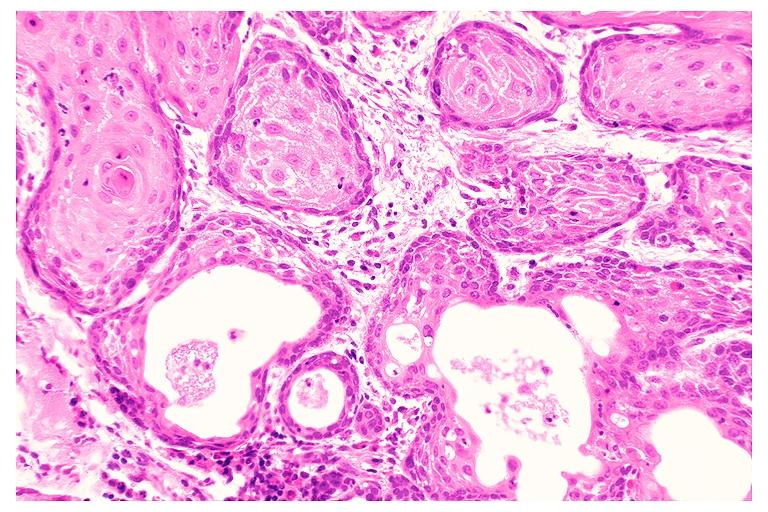what is present?
Answer the question using a single word or phrase. Oral 